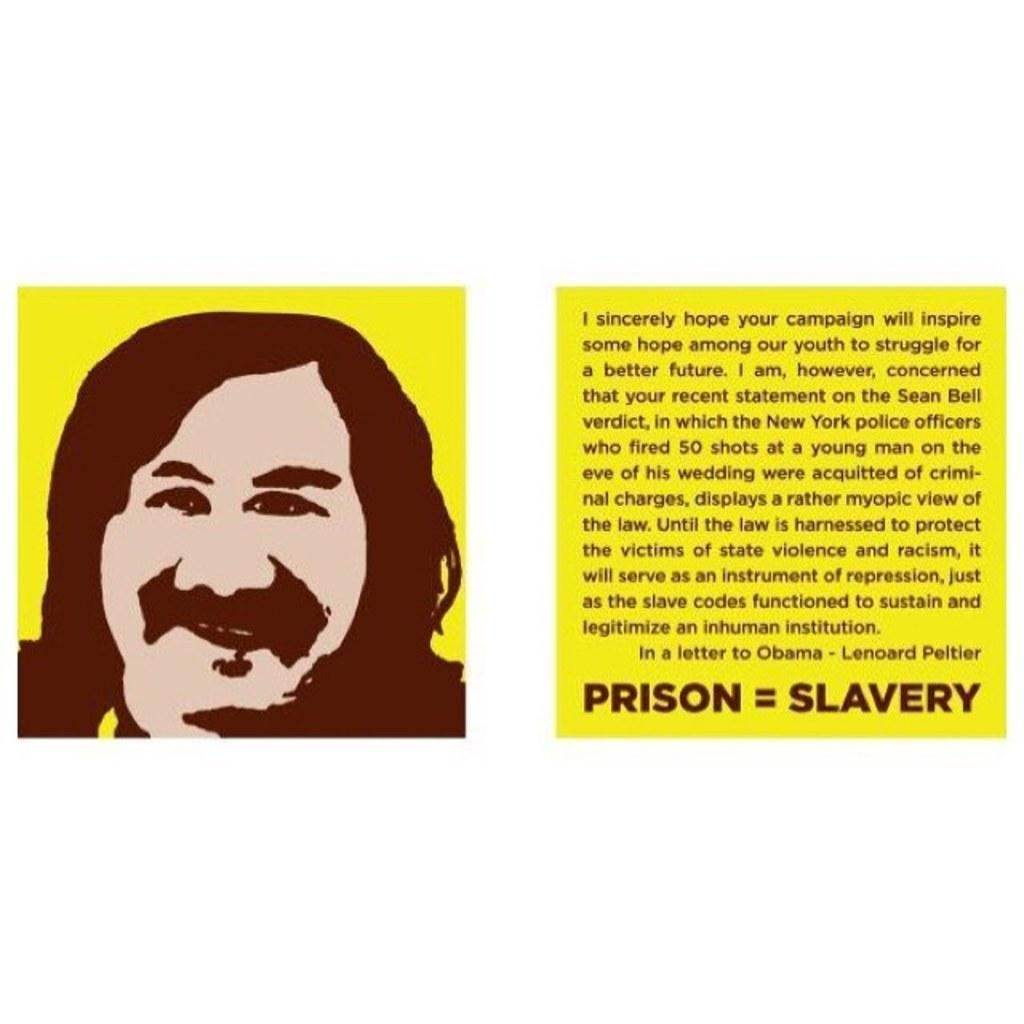What is the main subject of the image? The main subject of the image is a picture of a man. What else can be seen in the image besides the man? There is text in the image. How far is the ocean from the man in the image? There is no ocean present in the image, so it is not possible to determine its distance from the man. 